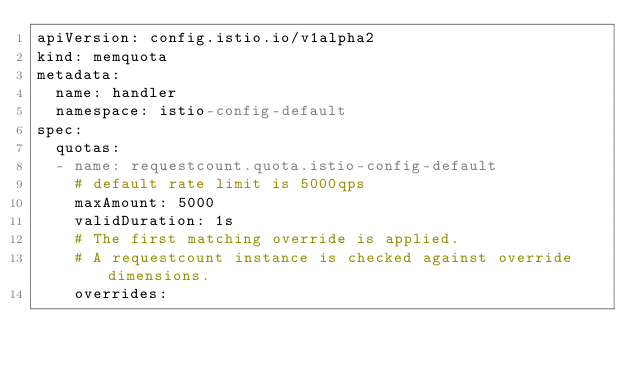Convert code to text. <code><loc_0><loc_0><loc_500><loc_500><_YAML_>apiVersion: config.istio.io/v1alpha2
kind: memquota
metadata:
  name: handler
  namespace: istio-config-default
spec:
  quotas:
  - name: requestcount.quota.istio-config-default
    # default rate limit is 5000qps
    maxAmount: 5000
    validDuration: 1s
    # The first matching override is applied.
    # A requestcount instance is checked against override dimensions.
    overrides:</code> 